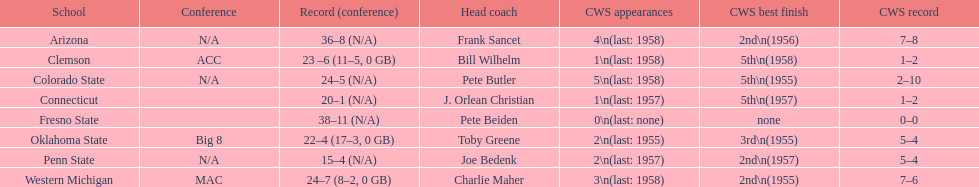Help me parse the entirety of this table. {'header': ['School', 'Conference', 'Record (conference)', 'Head coach', 'CWS appearances', 'CWS best finish', 'CWS record'], 'rows': [['Arizona', 'N/A', '36–8 (N/A)', 'Frank Sancet', '4\\n(last: 1958)', '2nd\\n(1956)', '7–8'], ['Clemson', 'ACC', '23 –6 (11–5, 0 GB)', 'Bill Wilhelm', '1\\n(last: 1958)', '5th\\n(1958)', '1–2'], ['Colorado State', 'N/A', '24–5 (N/A)', 'Pete Butler', '5\\n(last: 1958)', '5th\\n(1955)', '2–10'], ['Connecticut', '', '20–1 (N/A)', 'J. Orlean Christian', '1\\n(last: 1957)', '5th\\n(1957)', '1–2'], ['Fresno State', '', '38–11 (N/A)', 'Pete Beiden', '0\\n(last: none)', 'none', '0–0'], ['Oklahoma State', 'Big 8', '22–4 (17–3, 0 GB)', 'Toby Greene', '2\\n(last: 1955)', '3rd\\n(1955)', '5–4'], ['Penn State', 'N/A', '15–4 (N/A)', 'Joe Bedenk', '2\\n(last: 1957)', '2nd\\n(1957)', '5–4'], ['Western Michigan', 'MAC', '24–7 (8–2, 0 GB)', 'Charlie Maher', '3\\n(last: 1958)', '2nd\\n(1955)', '7–6']]} Itemize every school that secured 2nd position in cws best finish. Arizona, Penn State, Western Michigan. 